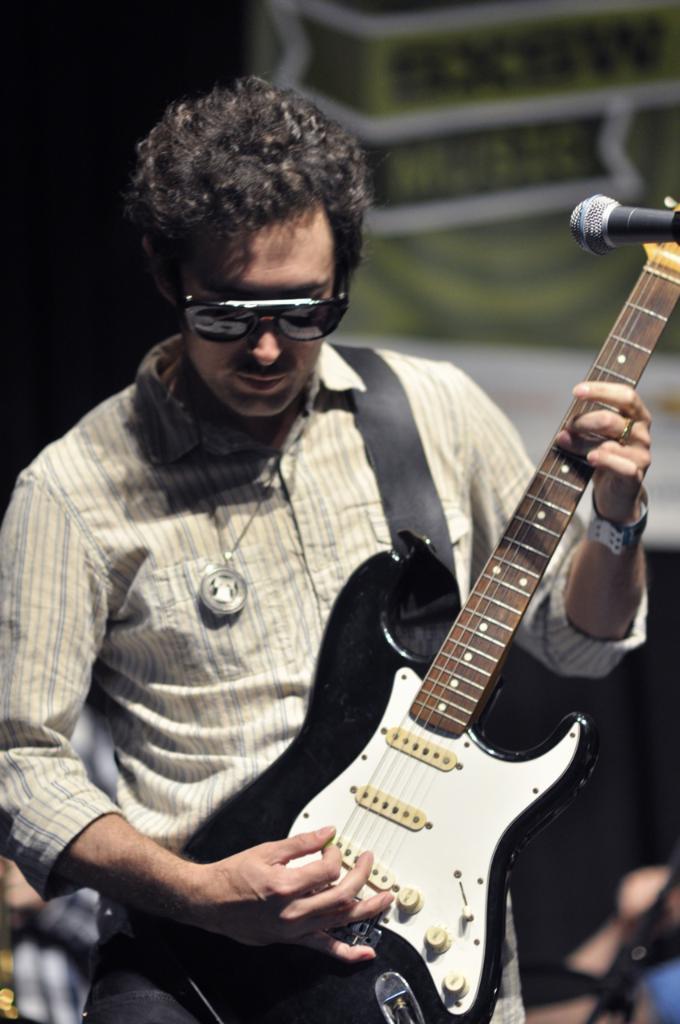How would you summarize this image in a sentence or two? In this image the man is holding a guitar and there is a mic. 